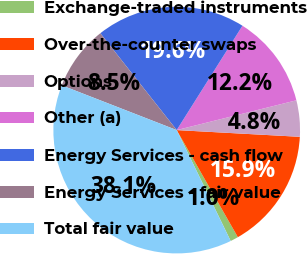<chart> <loc_0><loc_0><loc_500><loc_500><pie_chart><fcel>Exchange-traded instruments<fcel>Over-the-counter swaps<fcel>Options<fcel>Other (a)<fcel>Energy Services - cash flow<fcel>Energy Services - fair value<fcel>Total fair value<nl><fcel>1.05%<fcel>15.87%<fcel>4.75%<fcel>12.17%<fcel>19.58%<fcel>8.46%<fcel>38.12%<nl></chart> 